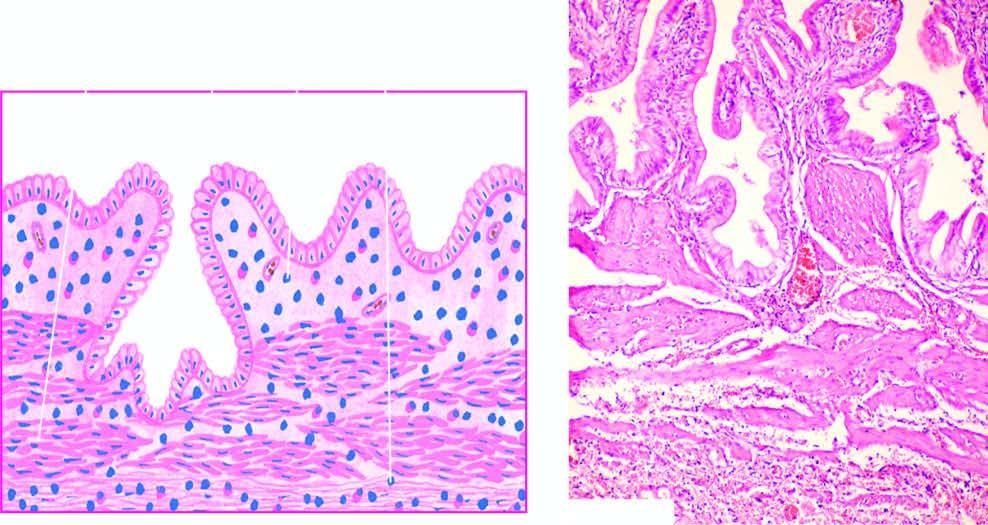what is there?
Answer the question using a single word or phrase. Subepithelial and subserosal fibrosis and hypertrophy of muscularis 